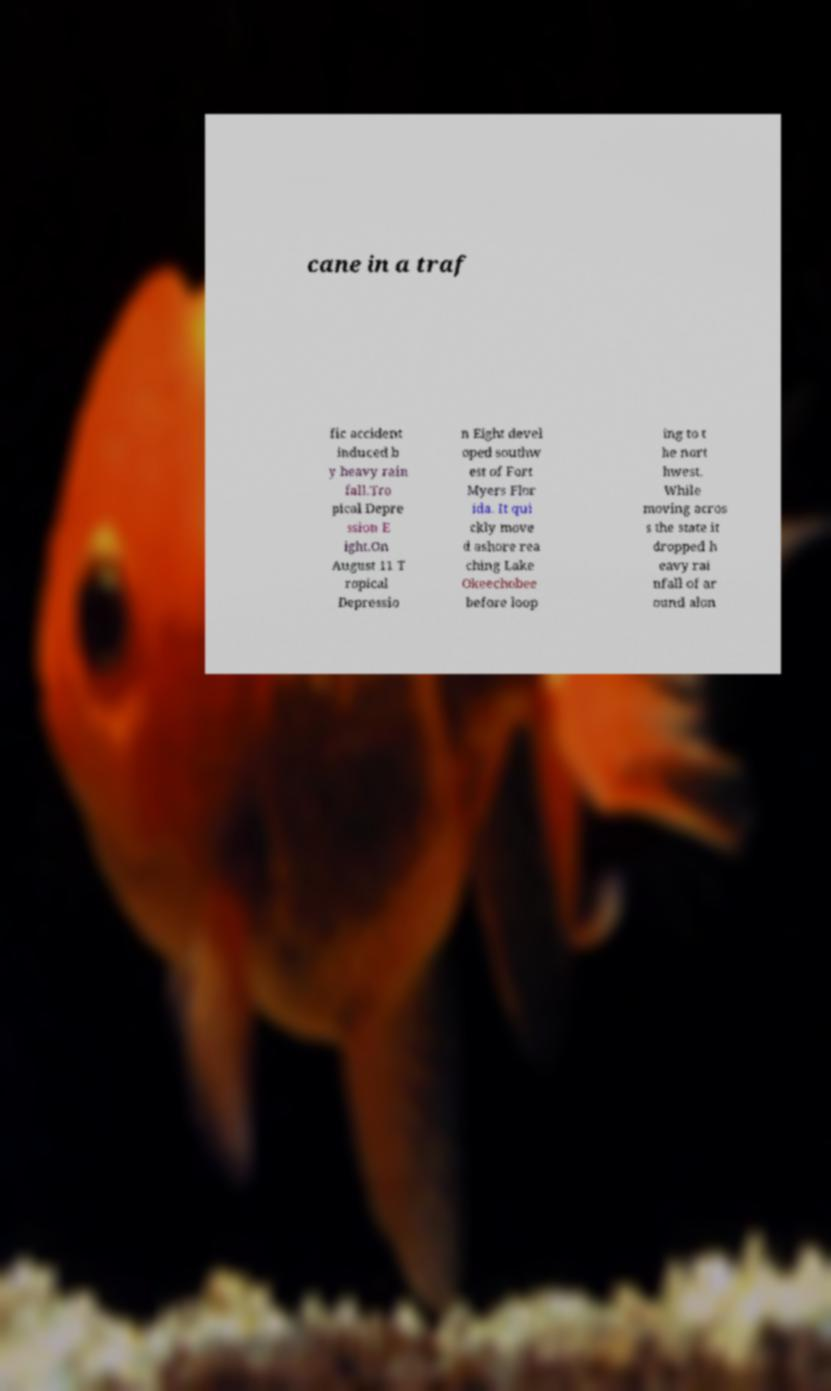Please identify and transcribe the text found in this image. cane in a traf fic accident induced b y heavy rain fall.Tro pical Depre ssion E ight.On August 11 T ropical Depressio n Eight devel oped southw est of Fort Myers Flor ida. It qui ckly move d ashore rea ching Lake Okeechobee before loop ing to t he nort hwest. While moving acros s the state it dropped h eavy rai nfall of ar ound alon 